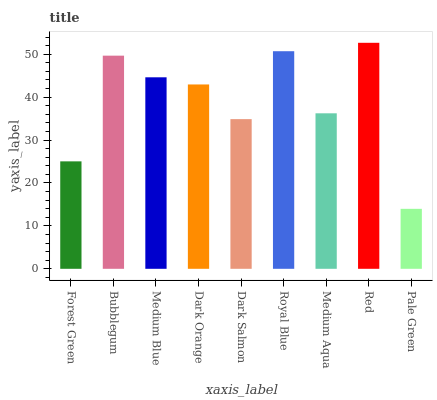Is Pale Green the minimum?
Answer yes or no. Yes. Is Red the maximum?
Answer yes or no. Yes. Is Bubblegum the minimum?
Answer yes or no. No. Is Bubblegum the maximum?
Answer yes or no. No. Is Bubblegum greater than Forest Green?
Answer yes or no. Yes. Is Forest Green less than Bubblegum?
Answer yes or no. Yes. Is Forest Green greater than Bubblegum?
Answer yes or no. No. Is Bubblegum less than Forest Green?
Answer yes or no. No. Is Dark Orange the high median?
Answer yes or no. Yes. Is Dark Orange the low median?
Answer yes or no. Yes. Is Medium Blue the high median?
Answer yes or no. No. Is Forest Green the low median?
Answer yes or no. No. 